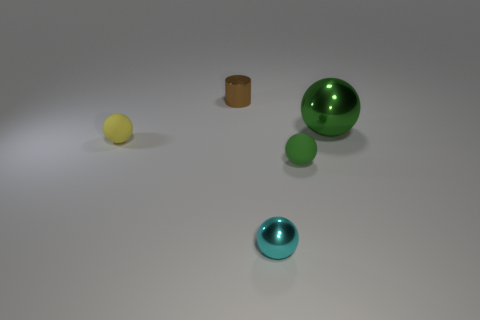Subtract all yellow balls. Subtract all gray blocks. How many balls are left? 3 Add 1 small brown rubber cylinders. How many objects exist? 6 Subtract all cylinders. How many objects are left? 4 Subtract all small matte objects. Subtract all tiny brown cylinders. How many objects are left? 2 Add 3 small matte things. How many small matte things are left? 5 Add 3 green spheres. How many green spheres exist? 5 Subtract 0 red blocks. How many objects are left? 5 